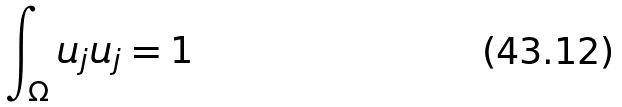Convert formula to latex. <formula><loc_0><loc_0><loc_500><loc_500>\int _ { \Omega } u _ { j } u _ { j } = 1</formula> 